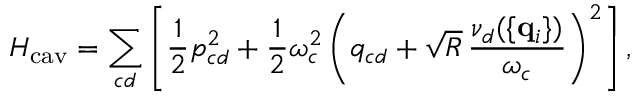Convert formula to latex. <formula><loc_0><loc_0><loc_500><loc_500>H _ { c a v } = \sum _ { c d } \left [ { \frac { 1 } { 2 } } { p } _ { c d } ^ { 2 } + { \frac { 1 } { 2 } } \omega _ { c } ^ { 2 } \left ( { q } _ { c d } + \sqrt { R } \, { \frac { \nu _ { d } ( \{ { q } _ { i } \} ) } { \omega _ { c } } } \right ) ^ { 2 } \right ] ,</formula> 